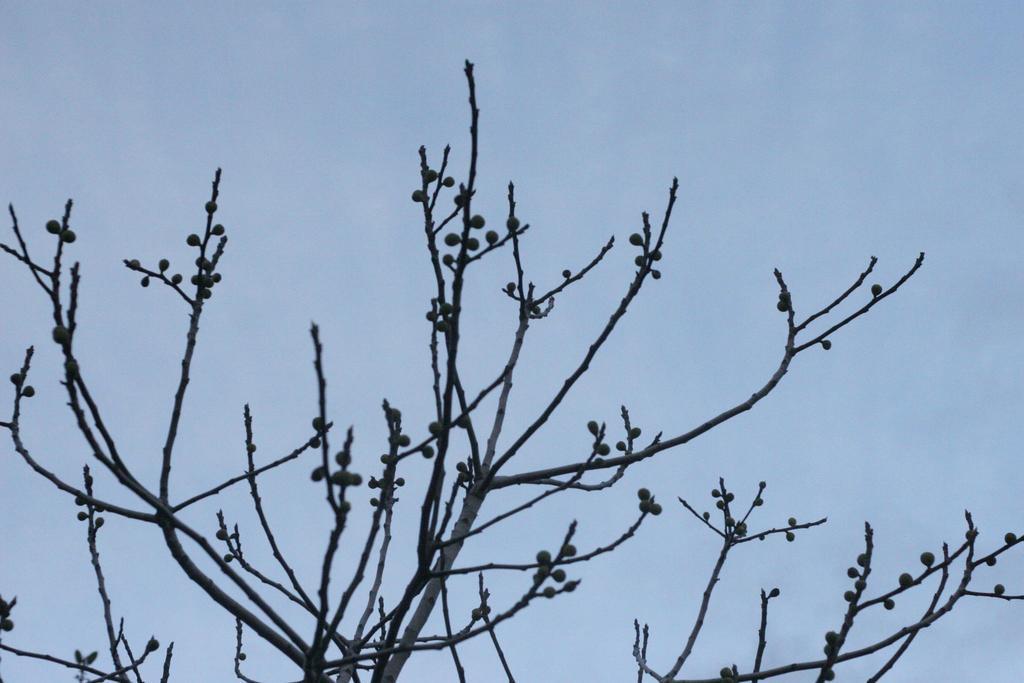Describe this image in one or two sentences. In this picture there is a tree and there might be fruits on the tree. At the top there is sky. 